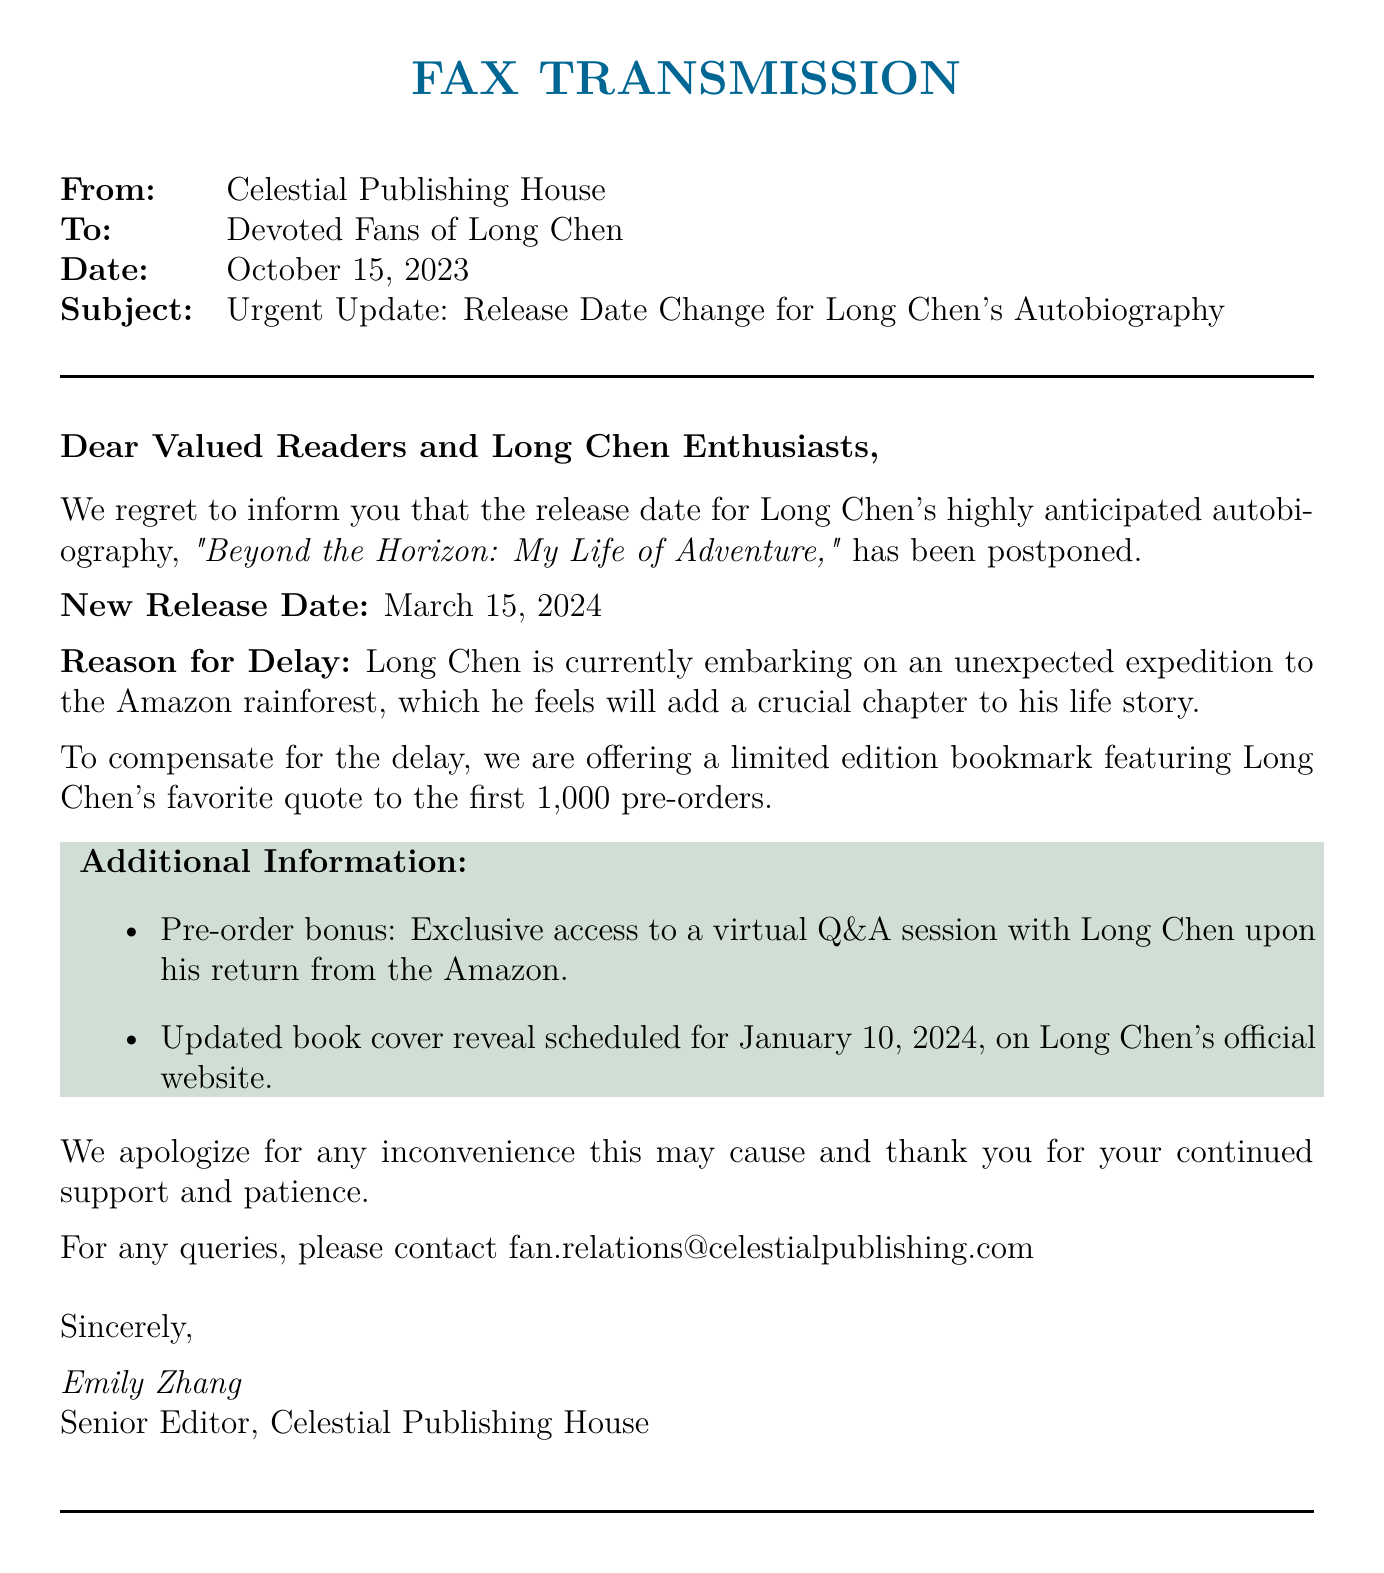What is the new release date for Long Chen's autobiography? The new release date is explicitly stated in the document as March 15, 2024.
Answer: March 15, 2024 Who is the sender of the fax? The sender is specified as Celestial Publishing House at the beginning of the document.
Answer: Celestial Publishing House What is the reason for the delay in the release? The reason for the delay is mentioned as Long Chen embarking on an unexpected expedition to the Amazon rainforest.
Answer: Unexpected expedition to the Amazon rainforest What is the title of Long Chen's autobiography? The title is highlighted in the document as "Beyond the Horizon: My Life of Adventure."
Answer: Beyond the Horizon: My Life of Adventure What is the pre-order bonus offered to the first 1,000 orders? The document states that a limited edition bookmark featuring Long Chen's favorite quote is offered as a pre-order bonus.
Answer: Limited edition bookmark When is the updated book cover reveal scheduled? The updated book cover reveal date is given as January 10, 2024, in the additional information section.
Answer: January 10, 2024 Who wrote the fax? The document includes the name of the person who wrote it, which is Emily Zhang, Senior Editor.
Answer: Emily Zhang What type of session will be available to pre-order customers? The document states that there will be exclusive access to a virtual Q&A session with Long Chen.
Answer: Virtual Q&A session 